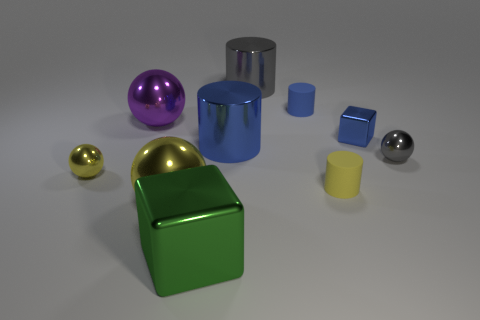Subtract all cylinders. How many objects are left? 6 Add 6 large cubes. How many large cubes are left? 7 Add 8 tiny blue things. How many tiny blue things exist? 10 Subtract 1 green blocks. How many objects are left? 9 Subtract all green matte things. Subtract all large purple objects. How many objects are left? 9 